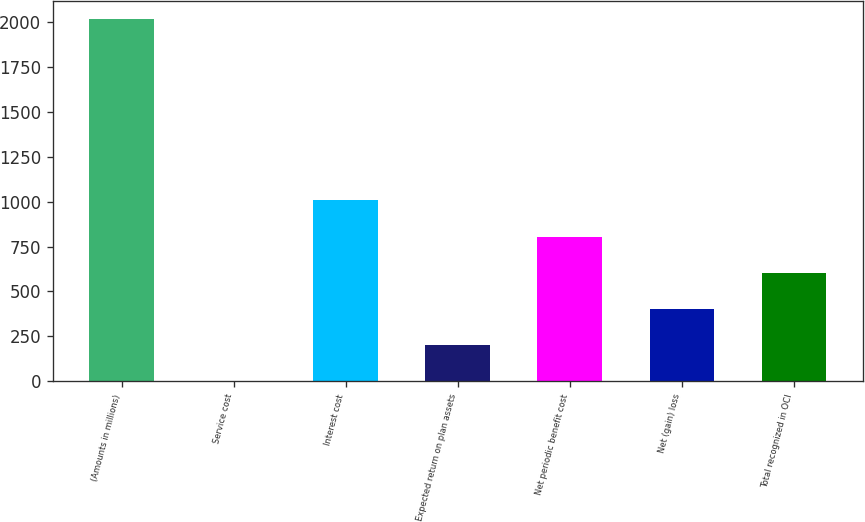Convert chart. <chart><loc_0><loc_0><loc_500><loc_500><bar_chart><fcel>(Amounts in millions)<fcel>Service cost<fcel>Interest cost<fcel>Expected return on plan assets<fcel>Net periodic benefit cost<fcel>Net (gain) loss<fcel>Total recognized in OCI<nl><fcel>2012<fcel>0.2<fcel>1006.1<fcel>201.38<fcel>804.92<fcel>402.56<fcel>603.74<nl></chart> 